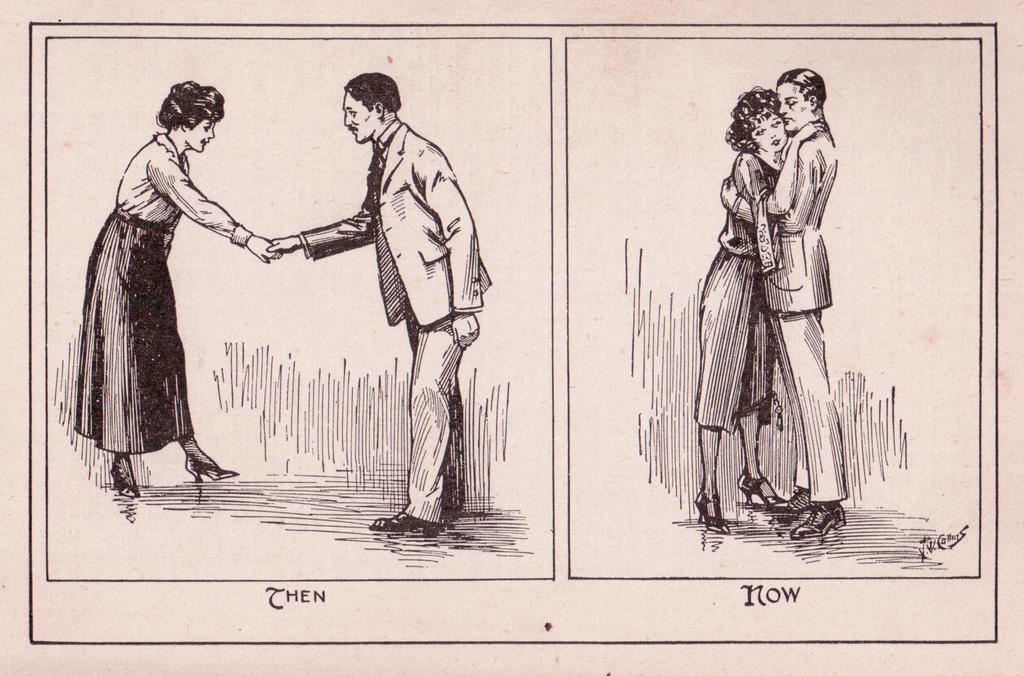Could you give a brief overview of what you see in this image? In this image there is a drawing, there are persons, there is text, the background of the image is white in color. 